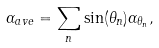Convert formula to latex. <formula><loc_0><loc_0><loc_500><loc_500>\alpha _ { a v e } = \sum _ { n } \sin ( \theta _ { n } ) \alpha _ { \theta _ { n } } ,</formula> 